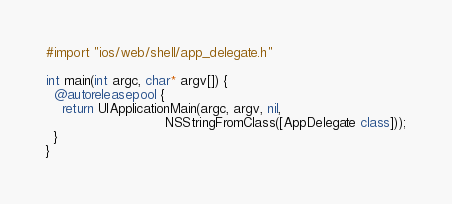<code> <loc_0><loc_0><loc_500><loc_500><_ObjectiveC_>#import "ios/web/shell/app_delegate.h"

int main(int argc, char* argv[]) {
  @autoreleasepool {
    return UIApplicationMain(argc, argv, nil,
                             NSStringFromClass([AppDelegate class]));
  }
}
</code> 